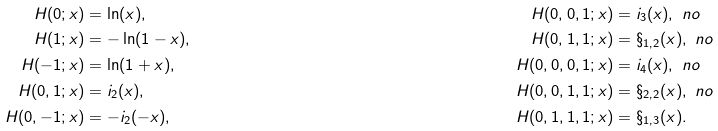<formula> <loc_0><loc_0><loc_500><loc_500>H ( 0 ; x ) & = \ln ( x ) , & H ( 0 , 0 , 1 ; x ) & = \L i _ { 3 } ( x ) , \ n o \\ H ( 1 ; x ) & = - \ln ( 1 - x ) , & H ( 0 , 1 , 1 ; x ) & = \S _ { 1 , 2 } ( x ) , \ n o \\ H ( - 1 ; x ) & = \ln ( 1 + x ) , & H ( 0 , 0 , 0 , 1 ; x ) & = \L i _ { 4 } ( x ) , \ n o \\ H ( 0 , 1 ; x ) & = \L i _ { 2 } ( x ) , & H ( 0 , 0 , 1 , 1 ; x ) & = \S _ { 2 , 2 } ( x ) , \ n o \\ H ( 0 , - 1 ; x ) & = - \L i _ { 2 } ( - x ) , & H ( 0 , 1 , 1 , 1 ; x ) & = \S _ { 1 , 3 } ( x ) .</formula> 